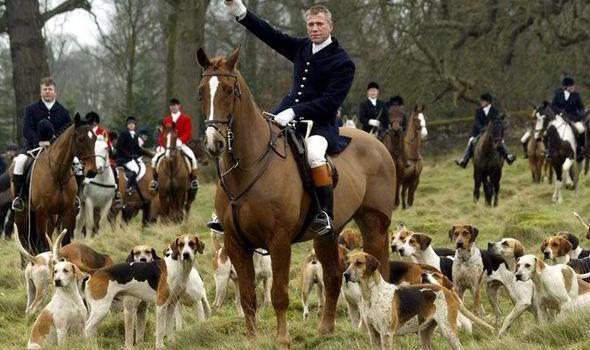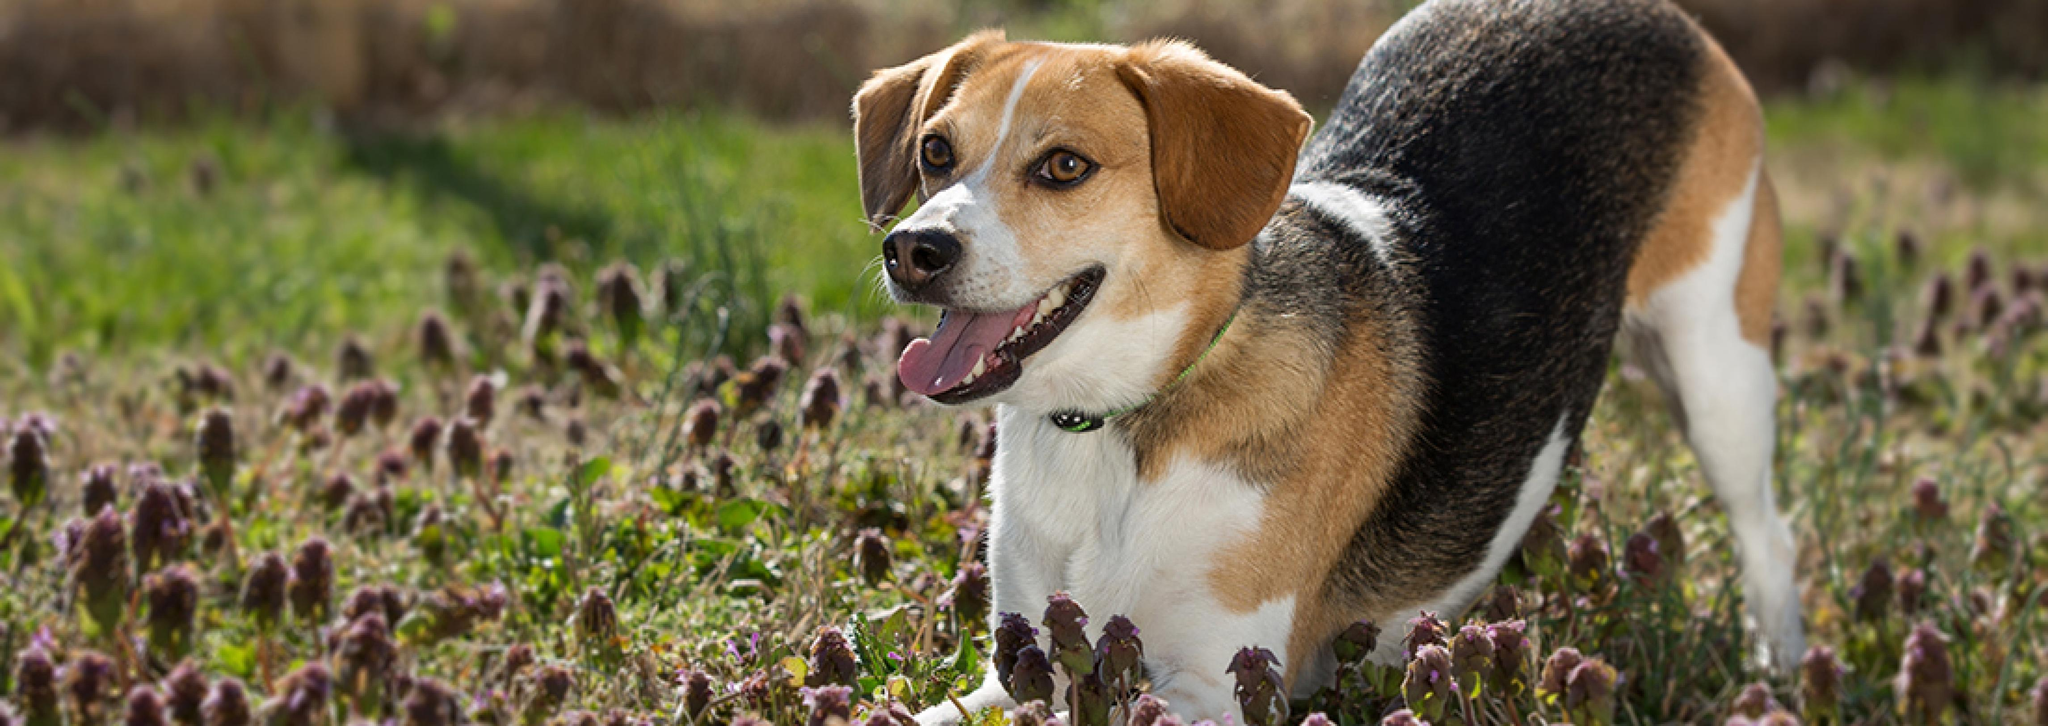The first image is the image on the left, the second image is the image on the right. Given the left and right images, does the statement "There is at least one person in a red jacket riding a horse in one of the images." hold true? Answer yes or no. Yes. The first image is the image on the left, the second image is the image on the right. Evaluate the accuracy of this statement regarding the images: "An image shows a man in white pants astride a horse in the foreground, and includes someone in a red jacket somewhere in the scene.". Is it true? Answer yes or no. Yes. 